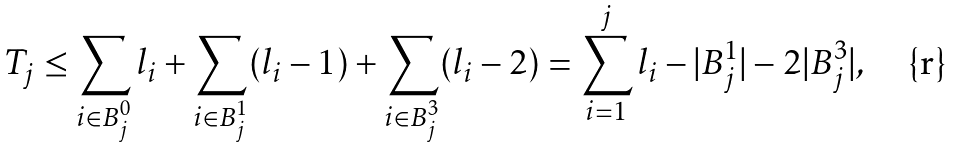<formula> <loc_0><loc_0><loc_500><loc_500>T _ { j } \leq \sum _ { i \in B _ { j } ^ { 0 } } l _ { i } + \sum _ { i \in B _ { j } ^ { 1 } } ( l _ { i } - 1 ) + \sum _ { i \in B _ { j } ^ { 3 } } ( l _ { i } - 2 ) = \sum _ { i = 1 } ^ { j } l _ { i } - | B _ { j } ^ { 1 } | - 2 | B _ { j } ^ { 3 } | ,</formula> 